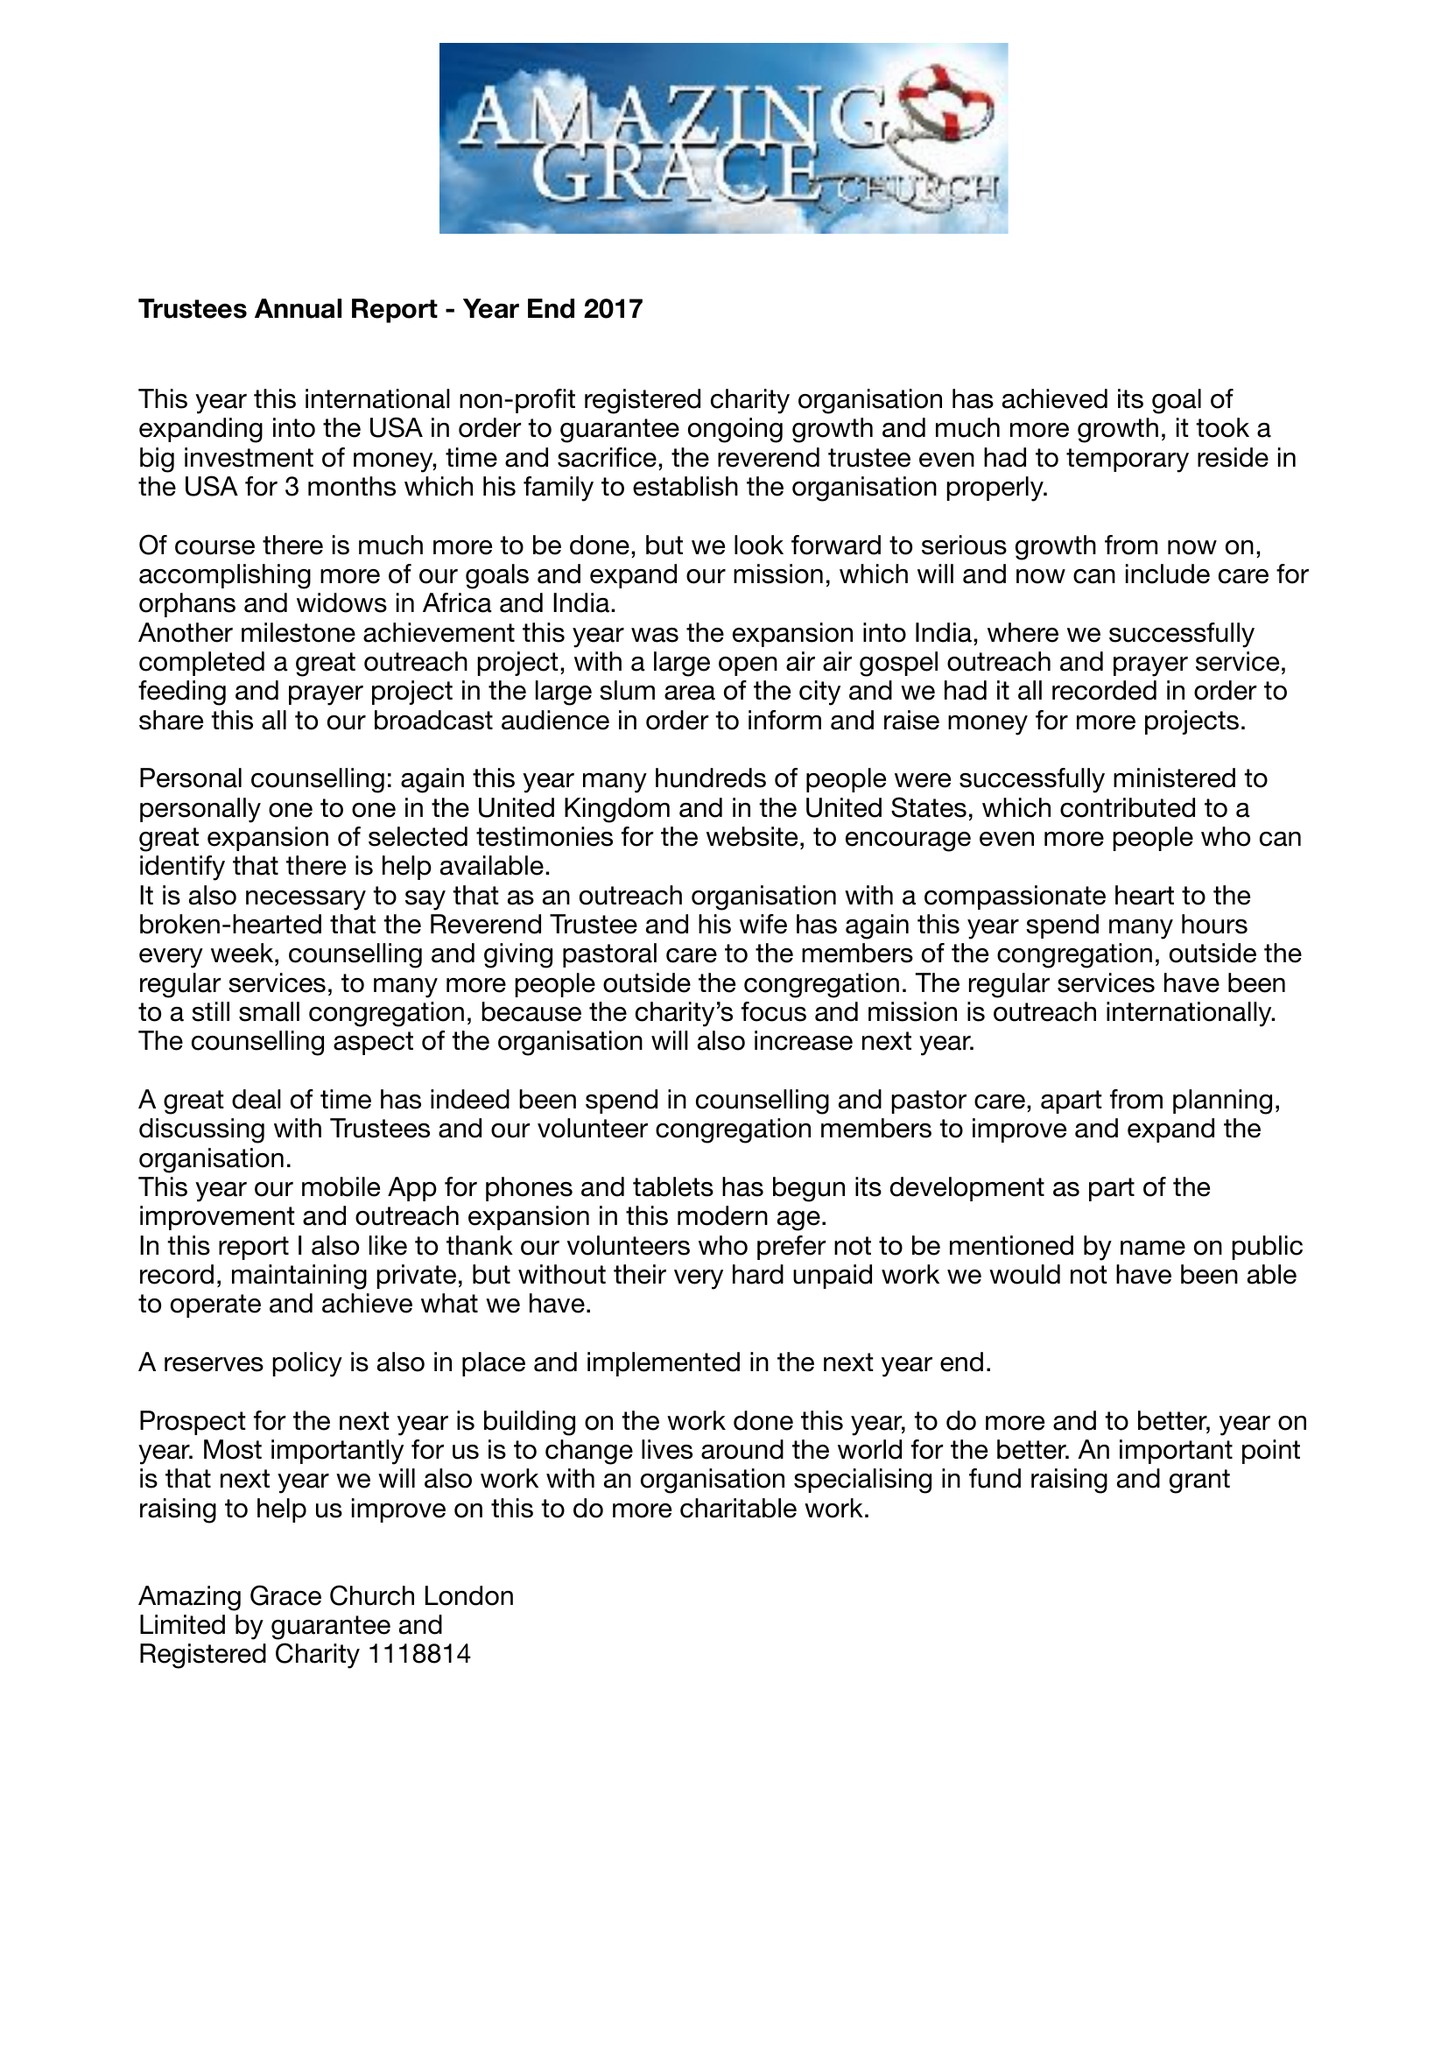What is the value for the address__postcode?
Answer the question using a single word or phrase. WC1N 3AX 